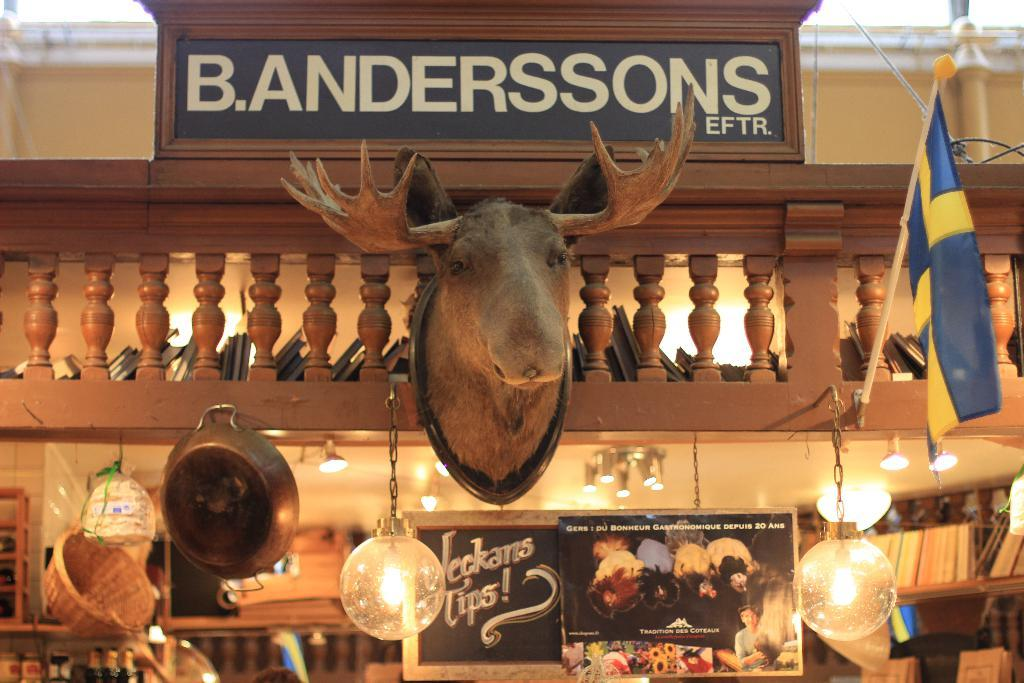What is hanging on the wall in the image? There is an animal stuffed face hanging on the wall in the image. What type of lighting is present in the image? There are ceiling lights visible in the image. What is the board in the image used for? The board in the image is used to display text. What can be seen on the board in the image? There is text written on a board in the image. What holiday is being celebrated in the image? There is no indication of a holiday being celebrated in the image. How many things are hanging from the line in the image? There is no line or things hanging from it in the image. 